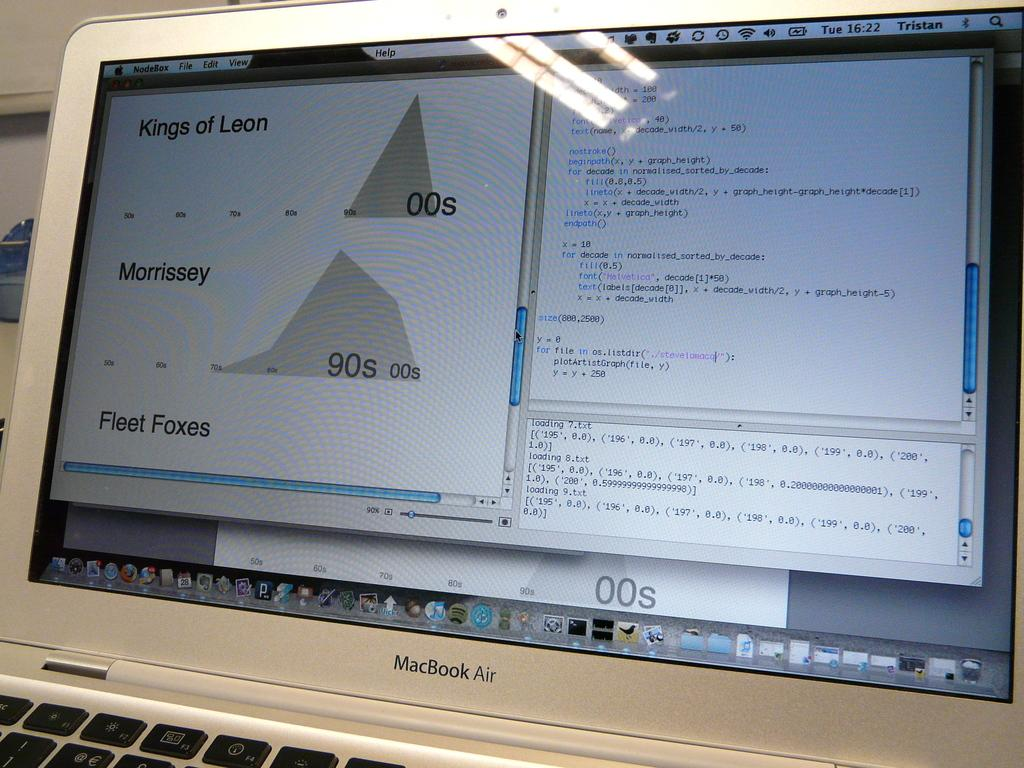<image>
Share a concise interpretation of the image provided. An open MacBook Air shows a Kings of Leon file. 